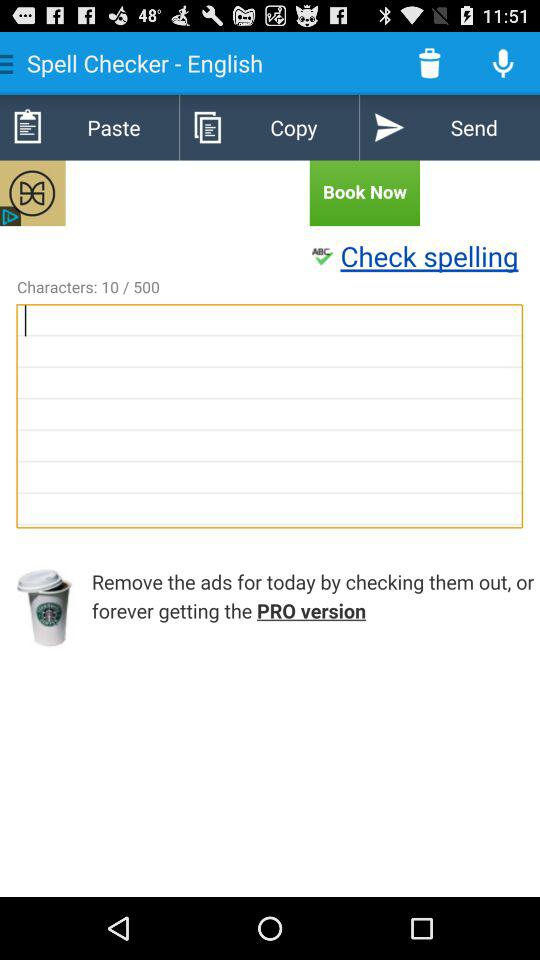What is the name of the application? The application name is "Spell Checker". 